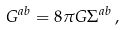Convert formula to latex. <formula><loc_0><loc_0><loc_500><loc_500>G ^ { a b } = 8 \pi G { \Sigma } ^ { a b } \, ,</formula> 